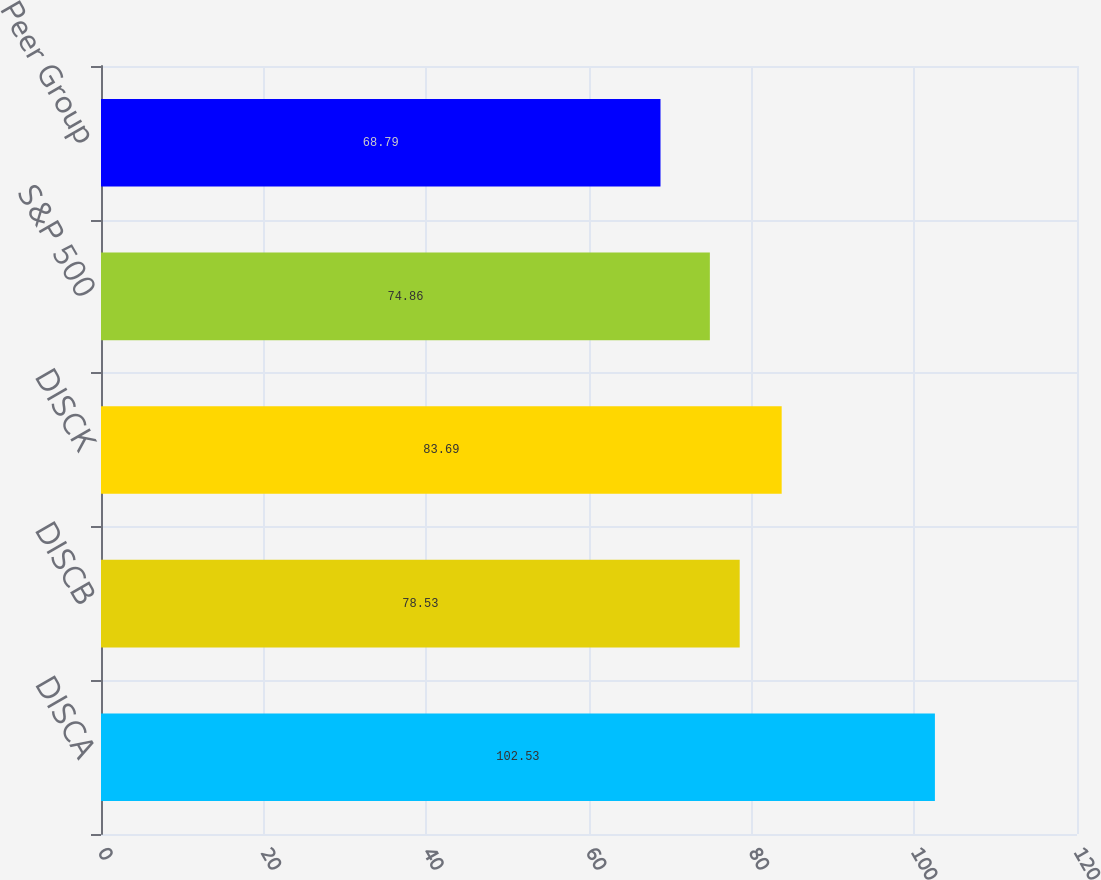Convert chart. <chart><loc_0><loc_0><loc_500><loc_500><bar_chart><fcel>DISCA<fcel>DISCB<fcel>DISCK<fcel>S&P 500<fcel>Peer Group<nl><fcel>102.53<fcel>78.53<fcel>83.69<fcel>74.86<fcel>68.79<nl></chart> 